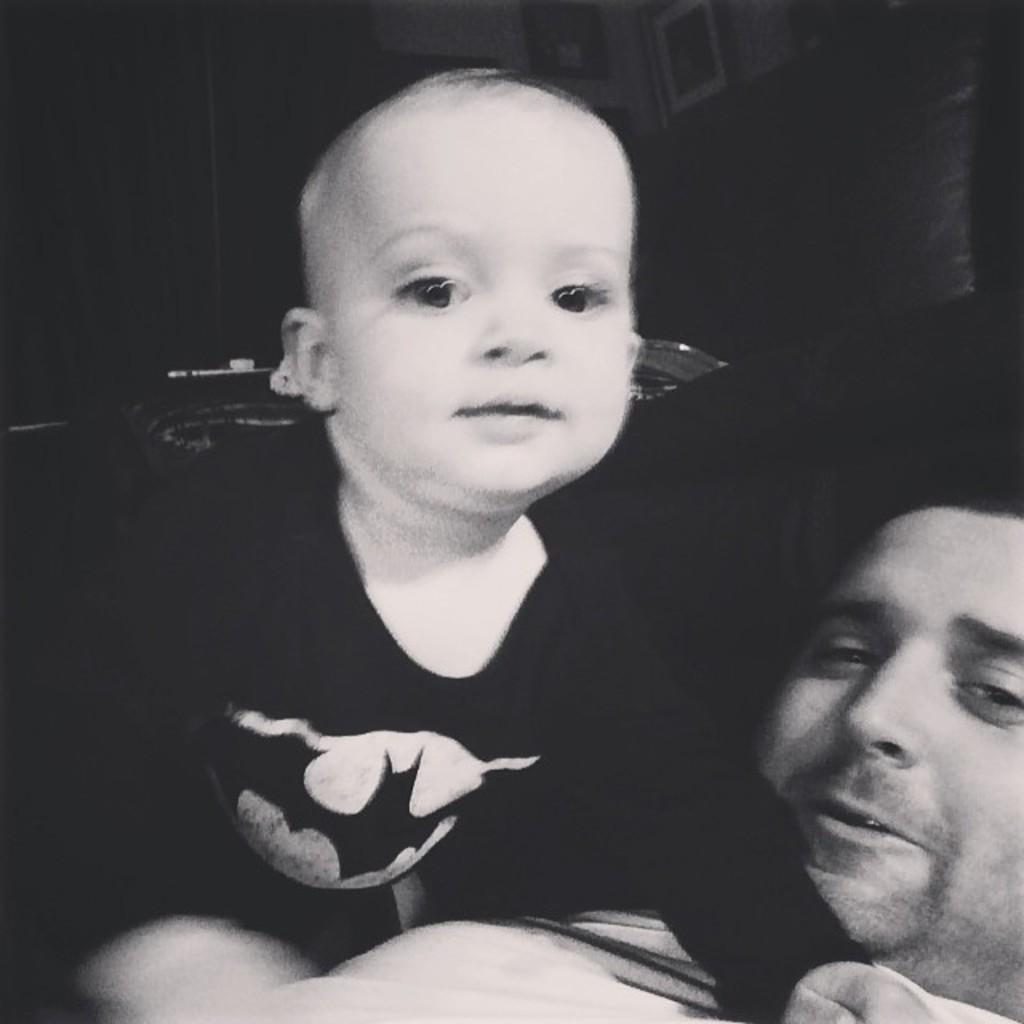Who is present in the image? There is a person and a kid in the image. What can be seen on the walls in the image? There are photo frames attached to the walls in the image. What is visible in the background of the image? There are objects in the background of the image. What type of sound can be heard coming from the mailbox in the image? There is no mailbox present in the image, so it is not possible to determine what, if any, sound might be heard. 